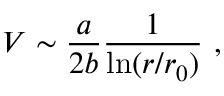Convert formula to latex. <formula><loc_0><loc_0><loc_500><loc_500>V \sim { \frac { a } { 2 b } } { \frac { 1 } { \ln ( r / r _ { 0 } ) } } ,</formula> 